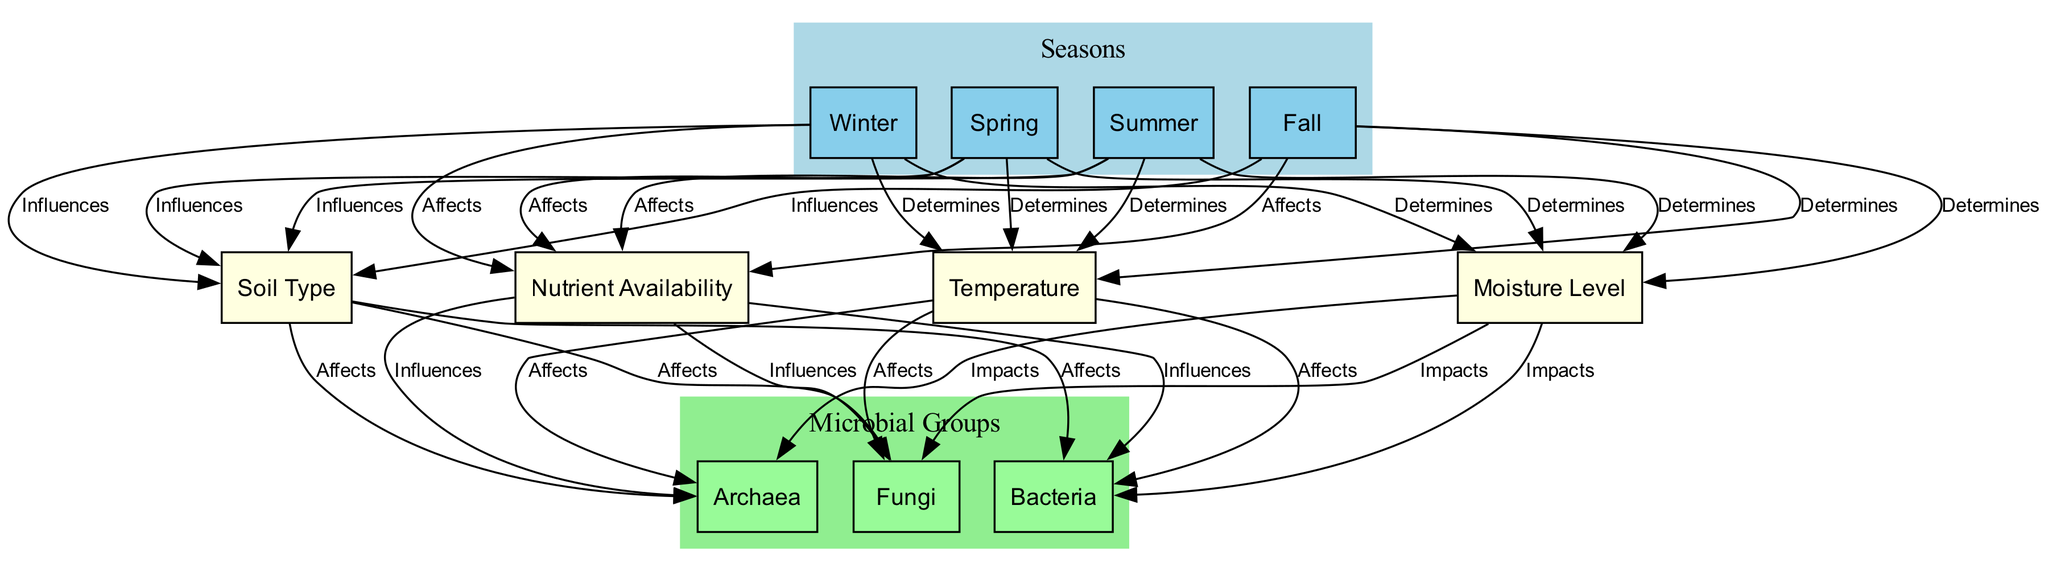What are the four seasons represented in the diagram? The diagram clearly shows four nodes corresponding to the seasons: Winter, Spring, Summer, and Fall.
Answer: Winter, Spring, Summer, Fall How many microbial groups are shown in the diagram? The diagram includes three microbial groups: Bacteria, Archaea, and Fungi. Therefore, counting these nodes gives a total of three distinct groups.
Answer: 3 Which season influences the moisture level? The diagram indicates all four seasons influence the moisture level, as there are direct edges from each seasonal node to the moisture level node.
Answer: All seasons What does the nutrient availability influence? The diagram shows that nutrient availability influences three microbial groups: Bacteria, Archaea, and Fungi. These are the nodes directly affected by nutrient availability.
Answer: Bacteria, Archaea, Fungi Which condition affects Bacteria the most? To determine the condition affecting Bacteria, we see that it is influenced by Soil Type, Moisture Level, Nutrient Availability, and Temperature. All these factors have edges leading to the Bacteria node.
Answer: Soil Type, Moisture Level, Nutrient Availability, Temperature If moisture level increases, how might it affect microbial communities? An increase in moisture level impacts Bacteria, Archaea, and Fungi. Therefore, if we consider moisture level increasing, it's likely that the populations of all three microbial groups may also increase as indicated by the edges connecting moisture level to these groups.
Answer: Bacteria, Archaea, Fungi How does temperature relate to Bacteria growth? The diagram shows that temperature affects Bacteria, indicating that changes in temperature could lead to changes in Bacteria growth. There is a direct edge from the temperature node to the Bacteria node which is crucial for understanding their relationship.
Answer: Affects What relationship does Soil Type have with Archaea? The diagram indicates that Soil Type affects Archaea, meaning that different soil types can lead to variations in Archaea populations or their community structures within the agricultural fields.
Answer: Affects Which season has the most influence on microbial community composition? Since all four seasons influence various factors (moisture level, nutrient availability, temperature, and soil type), the correct answer includes all seasons as they collectively impact the microbial community.
Answer: All seasons 